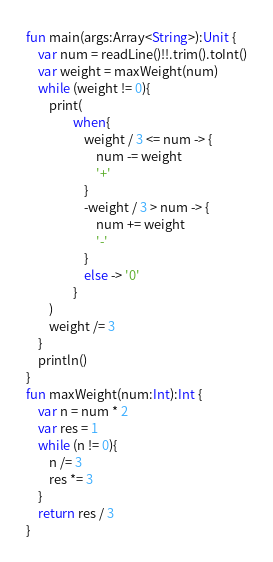<code> <loc_0><loc_0><loc_500><loc_500><_Kotlin_>
fun main(args:Array<String>):Unit {
    var num = readLine()!!.trim().toInt()
    var weight = maxWeight(num)
    while (weight != 0){
        print(
                when{
                    weight / 3 <= num -> {
                        num -= weight
                        '+'
                    }
                    -weight / 3 > num -> {
                        num += weight
                        '-'
                    }
                    else -> '0'
                }
        )
        weight /= 3
    }
    println()
}
fun maxWeight(num:Int):Int {
    var n = num * 2
    var res = 1
    while (n != 0){
        n /= 3
        res *= 3
    }
    return res / 3
}
</code> 